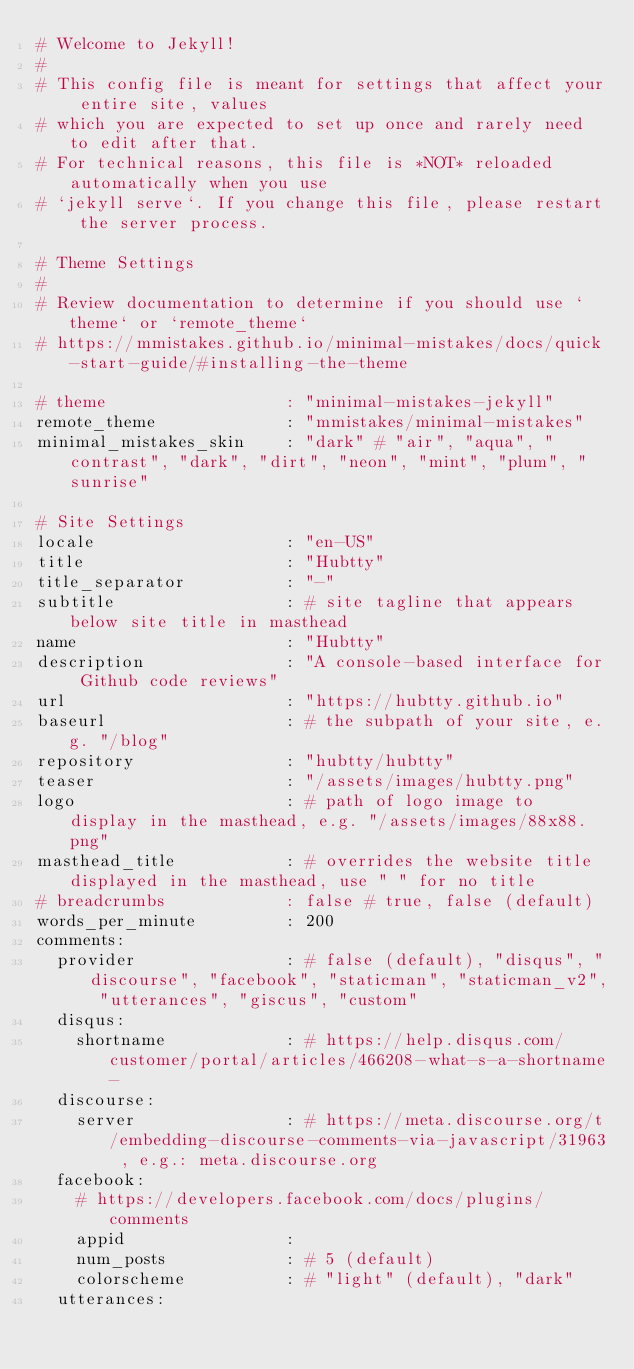<code> <loc_0><loc_0><loc_500><loc_500><_YAML_># Welcome to Jekyll!
#
# This config file is meant for settings that affect your entire site, values
# which you are expected to set up once and rarely need to edit after that.
# For technical reasons, this file is *NOT* reloaded automatically when you use
# `jekyll serve`. If you change this file, please restart the server process.

# Theme Settings
#
# Review documentation to determine if you should use `theme` or `remote_theme`
# https://mmistakes.github.io/minimal-mistakes/docs/quick-start-guide/#installing-the-theme

# theme                  : "minimal-mistakes-jekyll"
remote_theme             : "mmistakes/minimal-mistakes"
minimal_mistakes_skin    : "dark" # "air", "aqua", "contrast", "dark", "dirt", "neon", "mint", "plum", "sunrise"

# Site Settings
locale                   : "en-US"
title                    : "Hubtty"
title_separator          : "-"
subtitle                 : # site tagline that appears below site title in masthead
name                     : "Hubtty"
description              : "A console-based interface for Github code reviews"
url                      : "https://hubtty.github.io"
baseurl                  : # the subpath of your site, e.g. "/blog"
repository               : "hubtty/hubtty"
teaser                   : "/assets/images/hubtty.png"
logo                     : # path of logo image to display in the masthead, e.g. "/assets/images/88x88.png"
masthead_title           : # overrides the website title displayed in the masthead, use " " for no title
# breadcrumbs            : false # true, false (default)
words_per_minute         : 200
comments:
  provider               : # false (default), "disqus", "discourse", "facebook", "staticman", "staticman_v2", "utterances", "giscus", "custom"
  disqus:
    shortname            : # https://help.disqus.com/customer/portal/articles/466208-what-s-a-shortname-
  discourse:
    server               : # https://meta.discourse.org/t/embedding-discourse-comments-via-javascript/31963 , e.g.: meta.discourse.org
  facebook:
    # https://developers.facebook.com/docs/plugins/comments
    appid                :
    num_posts            : # 5 (default)
    colorscheme          : # "light" (default), "dark"
  utterances:</code> 